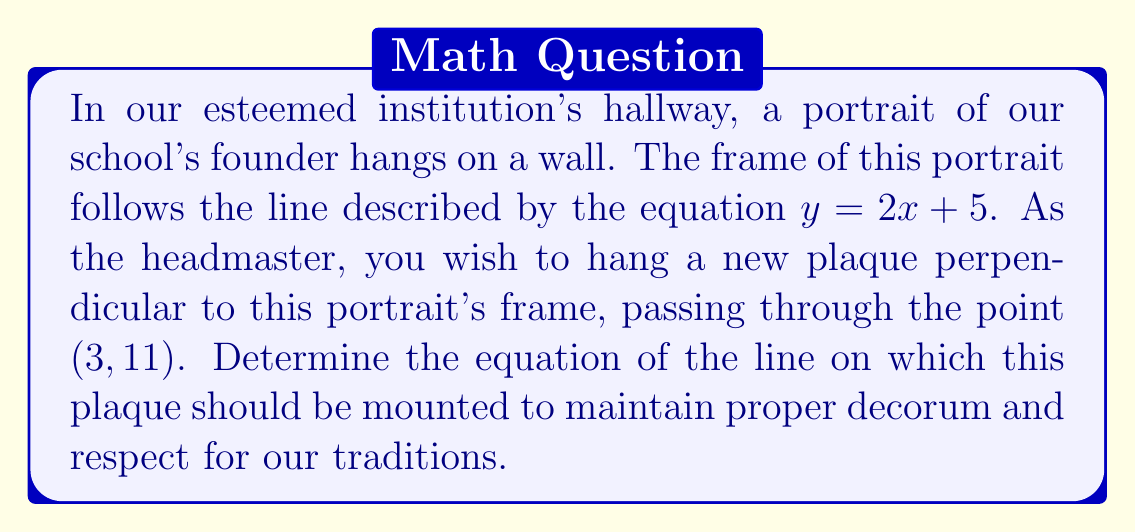What is the answer to this math problem? Let's approach this step-by-step:

1) First, recall that perpendicular lines have slopes that are negative reciprocals of each other. If the slope of one line is $m$, the slope of the line perpendicular to it is $-\frac{1}{m}$.

2) The given line has the equation $y = 2x + 5$. Its slope is 2.

3) Therefore, the slope of the perpendicular line will be $-\frac{1}{2}$.

4) We know a point that this perpendicular line passes through: $(3, 11)$.

5) We can use the point-slope form of a line equation:
   $y - y_1 = m(x - x_1)$
   where $(x_1, y_1)$ is the known point and $m$ is the slope.

6) Substituting our values:
   $y - 11 = -\frac{1}{2}(x - 3)$

7) Simplify:
   $y - 11 = -\frac{1}{2}x + \frac{3}{2}$

8) Add 11 to both sides:
   $y = -\frac{1}{2}x + \frac{3}{2} + 11$

9) Simplify:
   $y = -\frac{1}{2}x + \frac{25}{2}$

10) Multiply both sides by 2 to eliminate fractions:
    $2y = -x + 25$

11) Rearrange to standard form:
    $x + 2y = 25$
Answer: $x + 2y = 25$ 